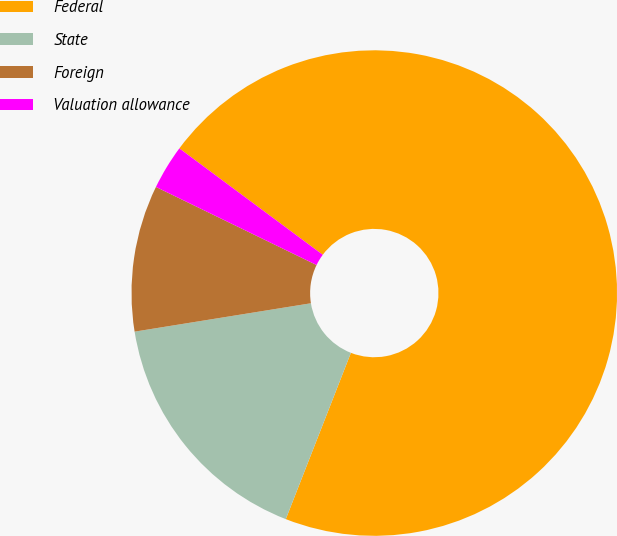Convert chart. <chart><loc_0><loc_0><loc_500><loc_500><pie_chart><fcel>Federal<fcel>State<fcel>Foreign<fcel>Valuation allowance<nl><fcel>70.77%<fcel>16.52%<fcel>9.74%<fcel>2.96%<nl></chart> 